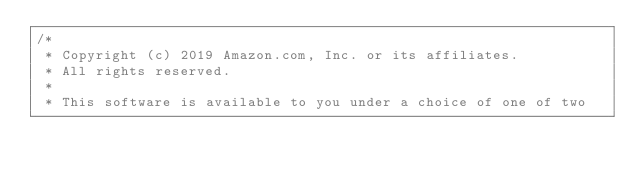<code> <loc_0><loc_0><loc_500><loc_500><_C_>/*
 * Copyright (c) 2019 Amazon.com, Inc. or its affiliates.
 * All rights reserved.
 *
 * This software is available to you under a choice of one of two</code> 